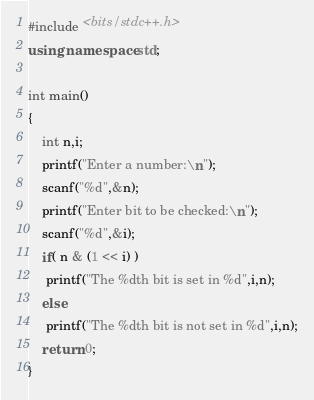Convert code to text. <code><loc_0><loc_0><loc_500><loc_500><_C++_>#include <bits/stdc++.h>
using namespace std;

int main()
{
	int n,i;
	printf("Enter a number:\n");
	scanf("%d",&n);
	printf("Enter bit to be checked:\n");
	scanf("%d",&i);
    if( n & (1 << i) )
     printf("The %dth bit is set in %d",i,n);
    else
     printf("The %dth bit is not set in %d",i,n);
    return 0;
}</code> 